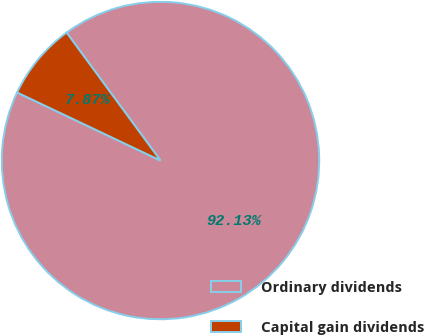<chart> <loc_0><loc_0><loc_500><loc_500><pie_chart><fcel>Ordinary dividends<fcel>Capital gain dividends<nl><fcel>92.13%<fcel>7.87%<nl></chart> 